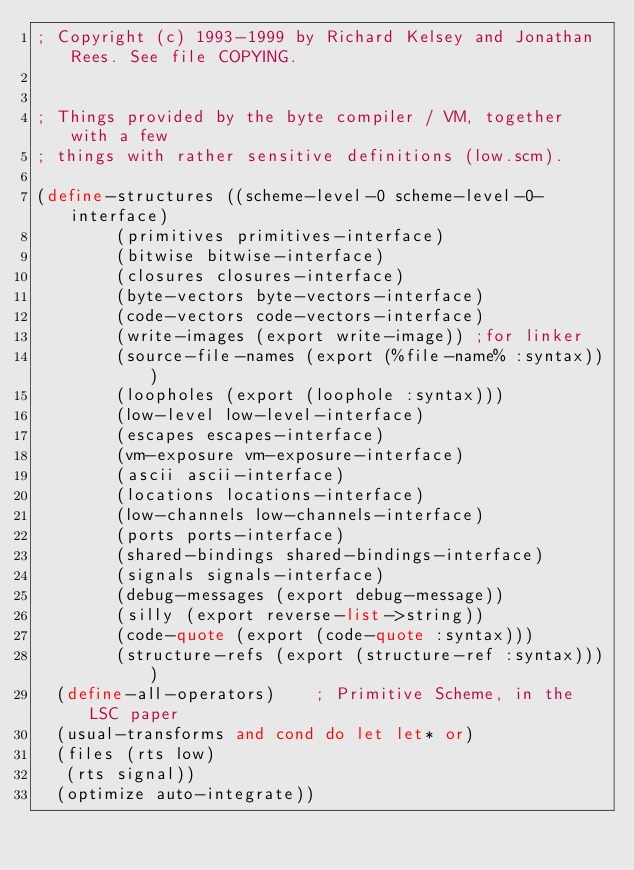<code> <loc_0><loc_0><loc_500><loc_500><_Scheme_>; Copyright (c) 1993-1999 by Richard Kelsey and Jonathan Rees. See file COPYING.


; Things provided by the byte compiler / VM, together with a few
; things with rather sensitive definitions (low.scm).

(define-structures ((scheme-level-0 scheme-level-0-interface)
		    (primitives primitives-interface)
		    (bitwise bitwise-interface)
		    (closures closures-interface)
		    (byte-vectors byte-vectors-interface)
		    (code-vectors code-vectors-interface)
		    (write-images (export write-image))	;for linker
		    (source-file-names (export (%file-name% :syntax)))
		    (loopholes (export (loophole :syntax)))
		    (low-level low-level-interface)
		    (escapes escapes-interface)
		    (vm-exposure vm-exposure-interface)
		    (ascii ascii-interface)
		    (locations locations-interface)
		    (low-channels low-channels-interface)
		    (ports ports-interface)
		    (shared-bindings shared-bindings-interface)
		    (signals signals-interface)
		    (debug-messages (export debug-message))
		    (silly (export reverse-list->string))
		    (code-quote (export (code-quote :syntax)))
		    (structure-refs (export (structure-ref :syntax))))
  (define-all-operators)		; Primitive Scheme, in the LSC paper
  (usual-transforms and cond do let let* or)
  (files (rts low)
	 (rts signal))
  (optimize auto-integrate))

</code> 